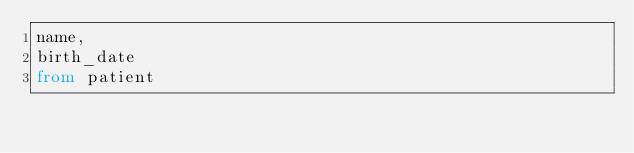Convert code to text. <code><loc_0><loc_0><loc_500><loc_500><_SQL_>name,
birth_date
from patient
</code> 